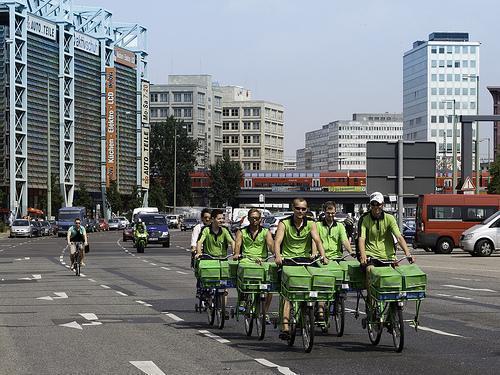How many people are on bicycles?
Give a very brief answer. 7. How many lanes does the road have?
Give a very brief answer. 4. How many of the bikers in the group are wearing a white baseball cap?
Give a very brief answer. 1. 